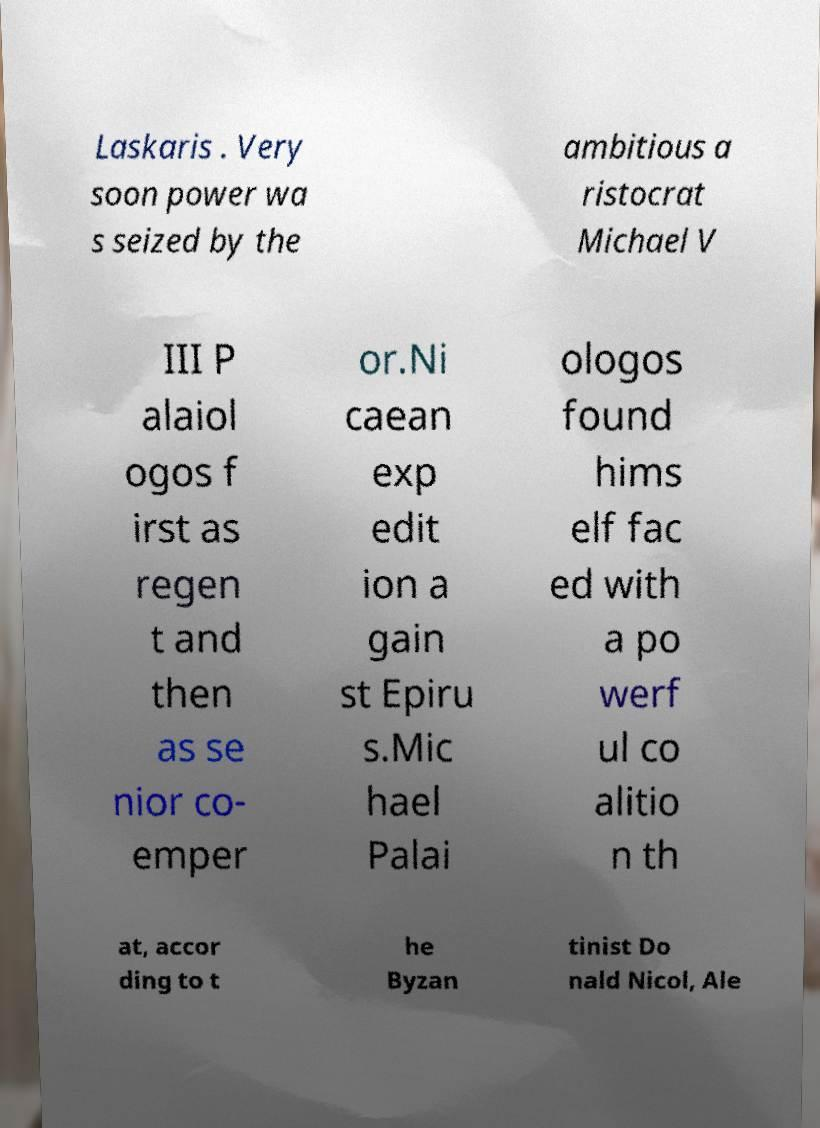For documentation purposes, I need the text within this image transcribed. Could you provide that? Laskaris . Very soon power wa s seized by the ambitious a ristocrat Michael V III P alaiol ogos f irst as regen t and then as se nior co- emper or.Ni caean exp edit ion a gain st Epiru s.Mic hael Palai ologos found hims elf fac ed with a po werf ul co alitio n th at, accor ding to t he Byzan tinist Do nald Nicol, Ale 